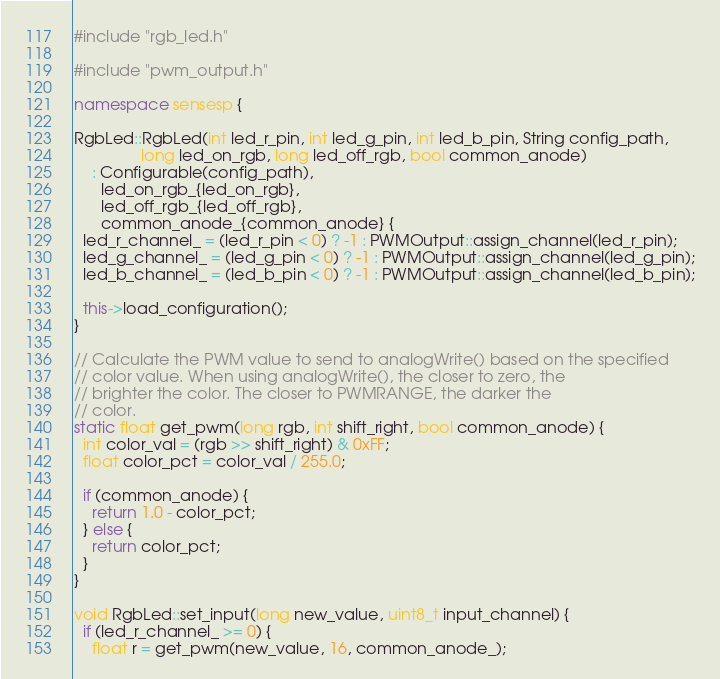<code> <loc_0><loc_0><loc_500><loc_500><_C++_>#include "rgb_led.h"

#include "pwm_output.h"

namespace sensesp {

RgbLed::RgbLed(int led_r_pin, int led_g_pin, int led_b_pin, String config_path,
               long led_on_rgb, long led_off_rgb, bool common_anode)
    : Configurable(config_path),
      led_on_rgb_{led_on_rgb},
      led_off_rgb_{led_off_rgb},
      common_anode_{common_anode} {
  led_r_channel_ = (led_r_pin < 0) ? -1 : PWMOutput::assign_channel(led_r_pin);
  led_g_channel_ = (led_g_pin < 0) ? -1 : PWMOutput::assign_channel(led_g_pin);
  led_b_channel_ = (led_b_pin < 0) ? -1 : PWMOutput::assign_channel(led_b_pin);

  this->load_configuration();
}

// Calculate the PWM value to send to analogWrite() based on the specified
// color value. When using analogWrite(), the closer to zero, the
// brighter the color. The closer to PWMRANGE, the darker the
// color.
static float get_pwm(long rgb, int shift_right, bool common_anode) {
  int color_val = (rgb >> shift_right) & 0xFF;
  float color_pct = color_val / 255.0;

  if (common_anode) {
    return 1.0 - color_pct;
  } else {
    return color_pct;
  }
}

void RgbLed::set_input(long new_value, uint8_t input_channel) {
  if (led_r_channel_ >= 0) {
    float r = get_pwm(new_value, 16, common_anode_);</code> 